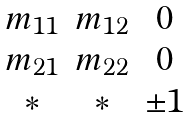Convert formula to latex. <formula><loc_0><loc_0><loc_500><loc_500>\begin{matrix} m _ { 1 1 } & m _ { 1 2 } & 0 \\ m _ { 2 1 } & m _ { 2 2 } & 0 \\ { * } & * & \pm 1 \end{matrix}</formula> 